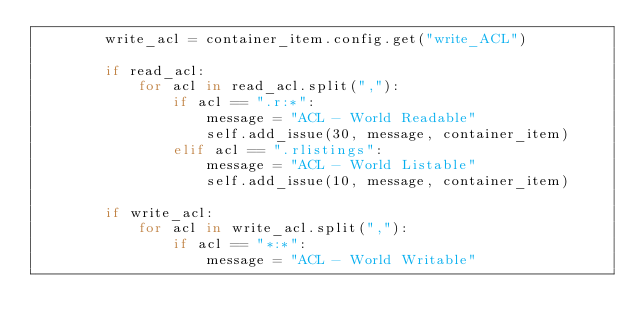<code> <loc_0><loc_0><loc_500><loc_500><_Python_>        write_acl = container_item.config.get("write_ACL")
        
        if read_acl:
            for acl in read_acl.split(","):
                if acl == ".r:*":
                    message = "ACL - World Readable"
                    self.add_issue(30, message, container_item)
                elif acl == ".rlistings":
                    message = "ACL - World Listable"
                    self.add_issue(10, message, container_item)

        if write_acl:
            for acl in write_acl.split(","):
                if acl == "*:*":
                    message = "ACL - World Writable"</code> 